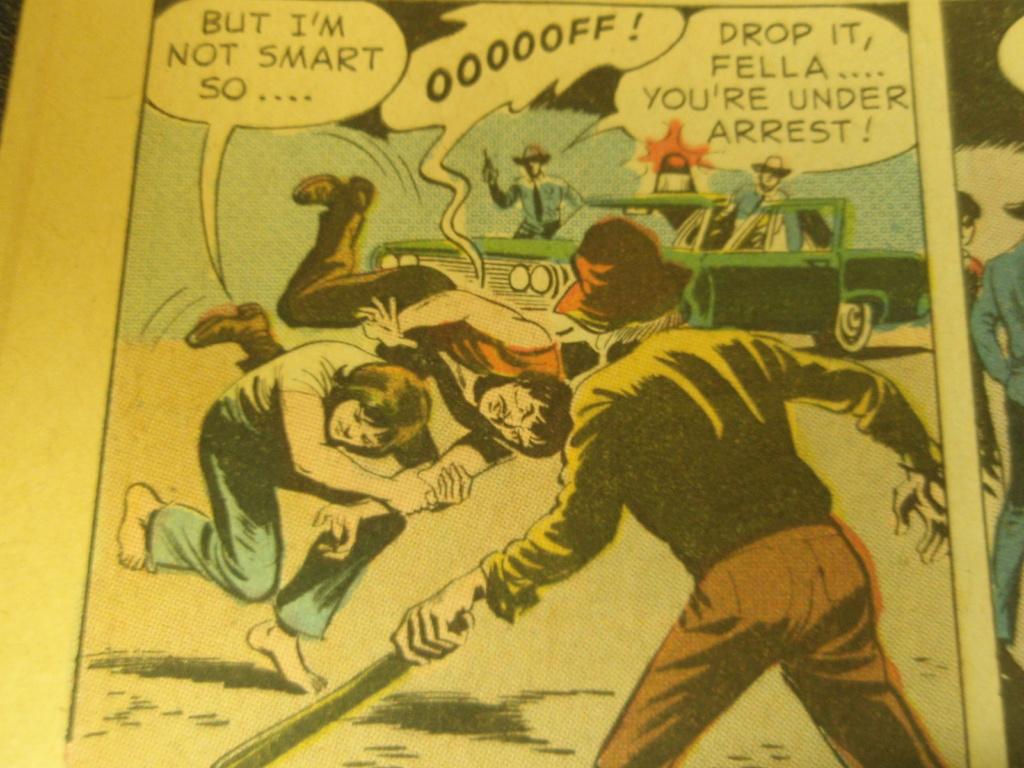What does the officer tell the nearby man to do?
Your answer should be very brief. Drop it. What does the person on the left say they're not?
Your answer should be compact. Smart. 